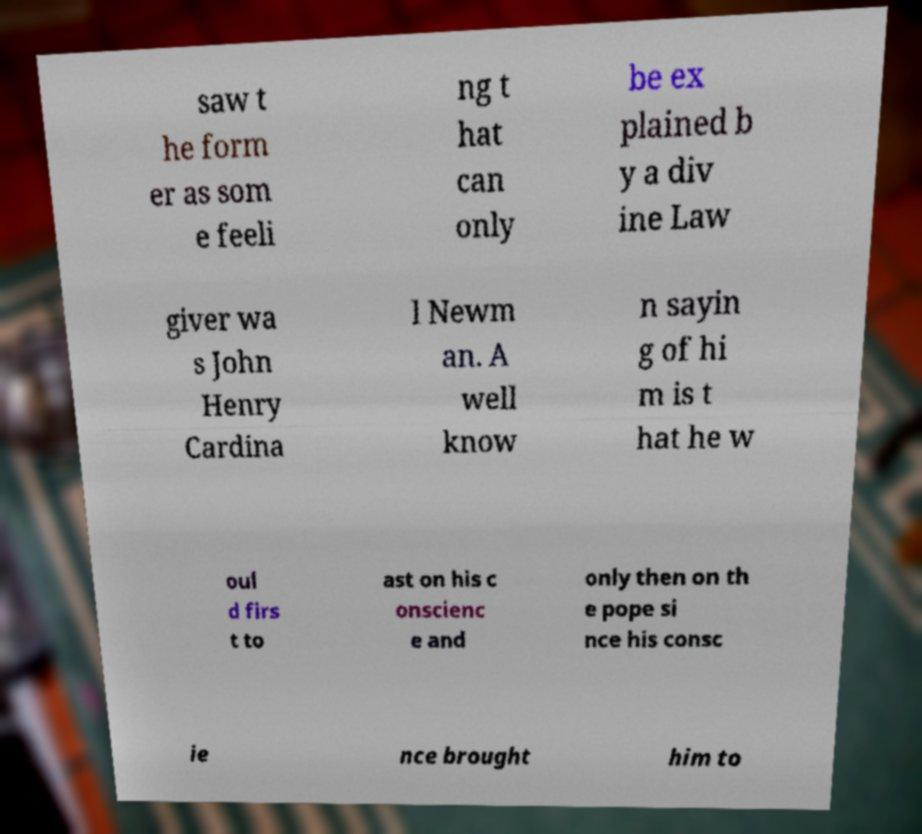There's text embedded in this image that I need extracted. Can you transcribe it verbatim? saw t he form er as som e feeli ng t hat can only be ex plained b y a div ine Law giver wa s John Henry Cardina l Newm an. A well know n sayin g of hi m is t hat he w oul d firs t to ast on his c onscienc e and only then on th e pope si nce his consc ie nce brought him to 